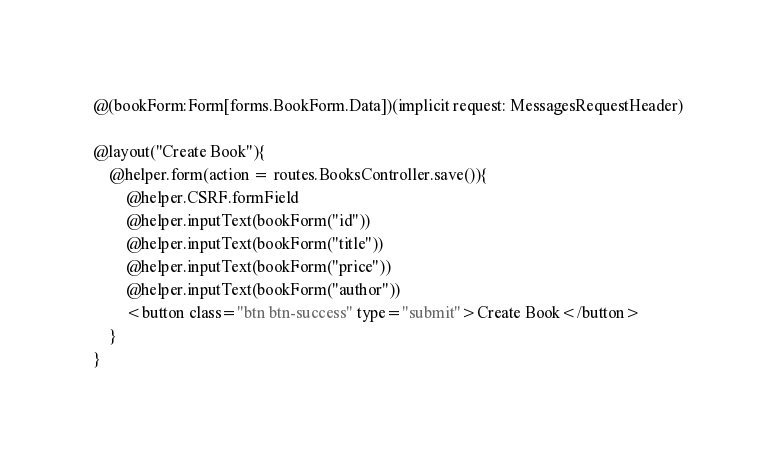Convert code to text. <code><loc_0><loc_0><loc_500><loc_500><_HTML_>@(bookForm:Form[forms.BookForm.Data])(implicit request: MessagesRequestHeader)

@layout("Create Book"){
    @helper.form(action = routes.BooksController.save()){
        @helper.CSRF.formField
        @helper.inputText(bookForm("id"))
        @helper.inputText(bookForm("title"))
        @helper.inputText(bookForm("price"))
        @helper.inputText(bookForm("author"))
        <button class="btn btn-success" type="submit">Create Book</button>
    }
}
</code> 